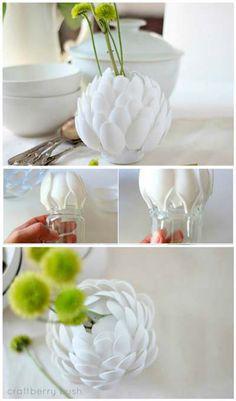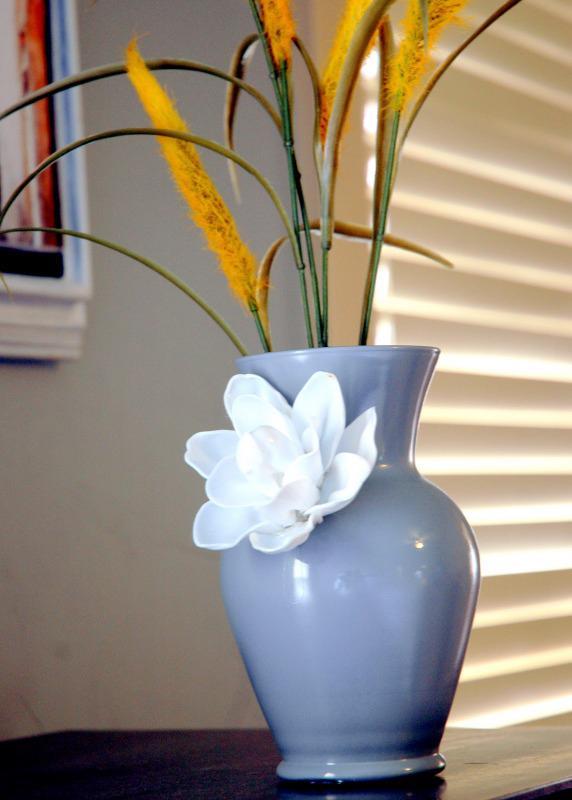The first image is the image on the left, the second image is the image on the right. For the images shown, is this caption "There is a plant in a blue vase." true? Answer yes or no. Yes. 